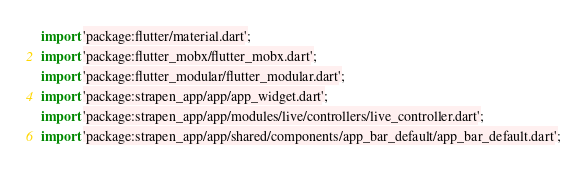Convert code to text. <code><loc_0><loc_0><loc_500><loc_500><_Dart_>import 'package:flutter/material.dart';
import 'package:flutter_mobx/flutter_mobx.dart';
import 'package:flutter_modular/flutter_modular.dart';
import 'package:strapen_app/app/app_widget.dart';
import 'package:strapen_app/app/modules/live/controllers/live_controller.dart';
import 'package:strapen_app/app/shared/components/app_bar_default/app_bar_default.dart';</code> 